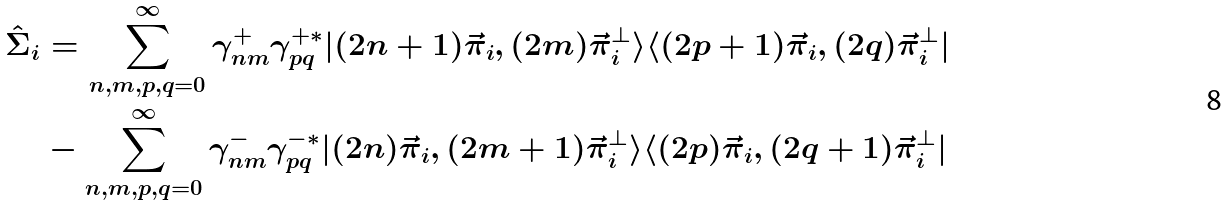<formula> <loc_0><loc_0><loc_500><loc_500>\hat { \Sigma } _ { i } & = \sum _ { n , m , p , q = 0 } ^ { \infty } \gamma ^ { + } _ { n m } \gamma _ { p q } ^ { + \ast } | ( 2 n + 1 ) \vec { \pi } _ { i } , ( 2 m ) \vec { \pi } ^ { \bot } _ { i } \rangle \langle ( 2 p + 1 ) \vec { \pi } _ { i } , ( 2 q ) \vec { \pi } ^ { \bot } _ { i } | \\ & - \sum _ { n , m , p , q = 0 } ^ { \infty } \gamma ^ { - } _ { n m } \gamma _ { p q } ^ { - \ast } | ( 2 n ) \vec { \pi } _ { i } , ( 2 m + 1 ) \vec { \pi } ^ { \bot } _ { i } \rangle \langle ( 2 p ) \vec { \pi } _ { i } , ( 2 q + 1 ) \vec { \pi } ^ { \bot } _ { i } |</formula> 